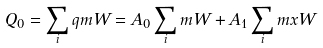<formula> <loc_0><loc_0><loc_500><loc_500>Q _ { 0 } = \sum _ { i } q m W = A _ { 0 } \sum _ { i } m W + A _ { 1 } \sum _ { i } m x W</formula> 